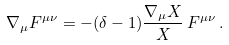<formula> <loc_0><loc_0><loc_500><loc_500>\nabla _ { \mu } F ^ { \mu \nu } = - ( \delta - 1 ) \frac { \nabla _ { \mu } X } { X } \, F ^ { \mu \nu } \, .</formula> 